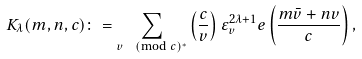<formula> <loc_0><loc_0><loc_500><loc_500>K _ { \lambda } ( m , n , c ) \colon = \sum _ { v \pmod { c } ^ { * } } \left ( \frac { c } { v } \right ) \varepsilon _ { v } ^ { 2 \lambda + 1 } e \left ( \frac { m \bar { v } + n v } { c } \right ) ,</formula> 